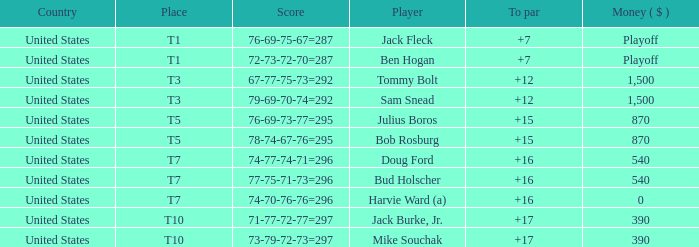Which money has player Jack Fleck with t1 place? Playoff. 